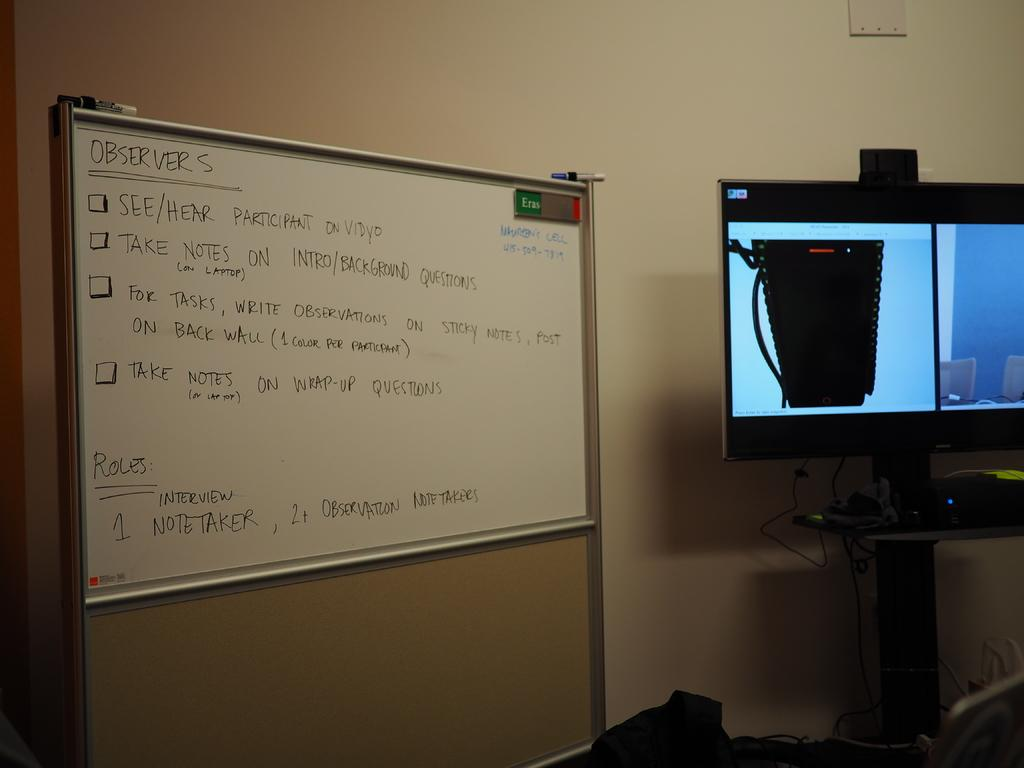<image>
Create a compact narrative representing the image presented. a white board with observers written on it 